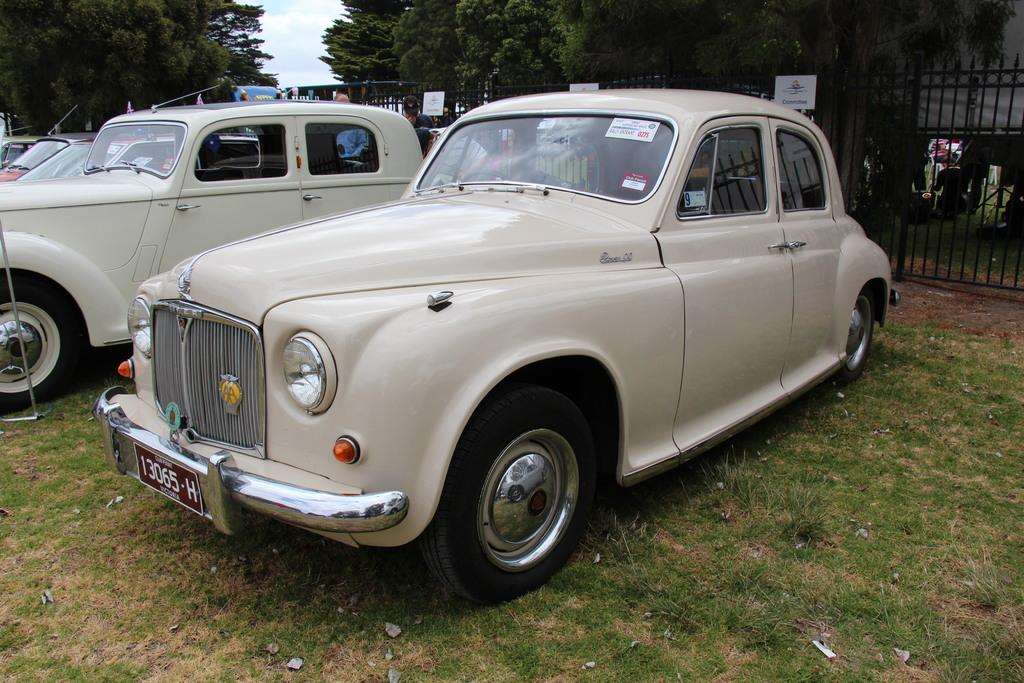What type of vehicles can be seen on the ground in the image? There are cars on the ground in the image. What structures can be seen in the background of the image? There are three fences and trees in the background of the image. What part of the natural environment is visible in the image? The sky and grass are visible in the image. What type of education is being taught in the image? There is no indication of any educational activity in the image. How does the image demonstrate respect for authority? The image does not depict any situation that would require respect for authority. 